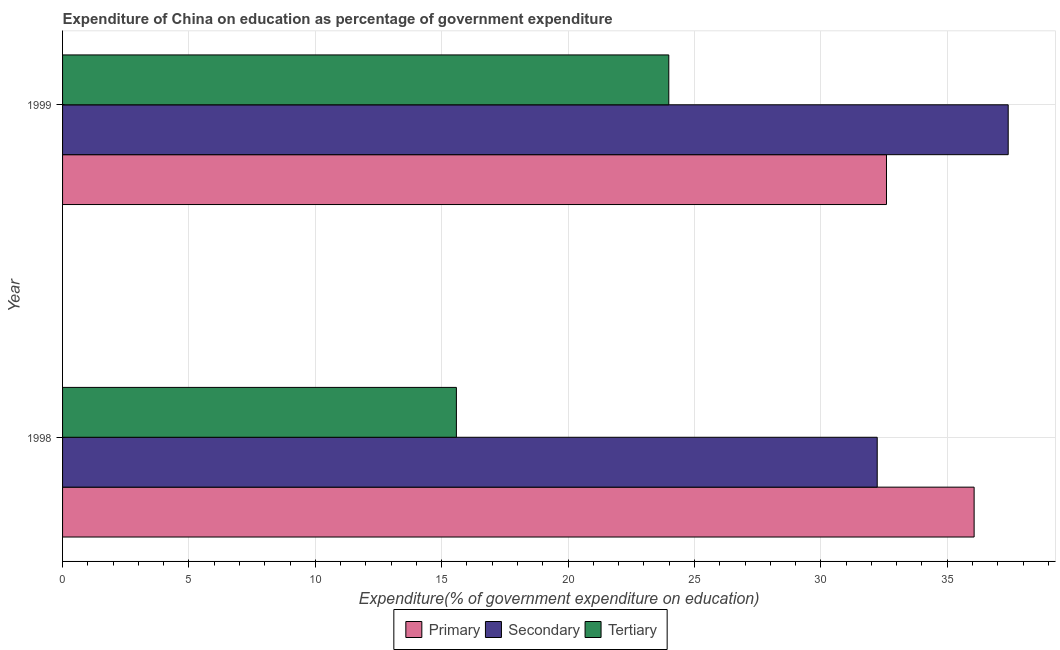How many groups of bars are there?
Provide a succinct answer. 2. How many bars are there on the 1st tick from the bottom?
Give a very brief answer. 3. What is the label of the 1st group of bars from the top?
Offer a terse response. 1999. In how many cases, is the number of bars for a given year not equal to the number of legend labels?
Ensure brevity in your answer.  0. What is the expenditure on secondary education in 1998?
Keep it short and to the point. 32.23. Across all years, what is the maximum expenditure on secondary education?
Make the answer very short. 37.41. Across all years, what is the minimum expenditure on primary education?
Provide a succinct answer. 32.6. In which year was the expenditure on tertiary education maximum?
Keep it short and to the point. 1999. In which year was the expenditure on tertiary education minimum?
Your answer should be compact. 1998. What is the total expenditure on secondary education in the graph?
Provide a succinct answer. 69.64. What is the difference between the expenditure on tertiary education in 1998 and that in 1999?
Your response must be concise. -8.4. What is the difference between the expenditure on secondary education in 1999 and the expenditure on primary education in 1998?
Keep it short and to the point. 1.35. What is the average expenditure on secondary education per year?
Your response must be concise. 34.82. In the year 1999, what is the difference between the expenditure on tertiary education and expenditure on primary education?
Make the answer very short. -8.61. What is the ratio of the expenditure on secondary education in 1998 to that in 1999?
Your answer should be compact. 0.86. Is the expenditure on secondary education in 1998 less than that in 1999?
Give a very brief answer. Yes. In how many years, is the expenditure on secondary education greater than the average expenditure on secondary education taken over all years?
Ensure brevity in your answer.  1. What does the 2nd bar from the top in 1998 represents?
Your answer should be compact. Secondary. What does the 3rd bar from the bottom in 1999 represents?
Ensure brevity in your answer.  Tertiary. Is it the case that in every year, the sum of the expenditure on primary education and expenditure on secondary education is greater than the expenditure on tertiary education?
Provide a succinct answer. Yes. How many bars are there?
Give a very brief answer. 6. How many years are there in the graph?
Provide a succinct answer. 2. What is the difference between two consecutive major ticks on the X-axis?
Make the answer very short. 5. Are the values on the major ticks of X-axis written in scientific E-notation?
Provide a short and direct response. No. Does the graph contain grids?
Keep it short and to the point. Yes. How are the legend labels stacked?
Your response must be concise. Horizontal. What is the title of the graph?
Provide a succinct answer. Expenditure of China on education as percentage of government expenditure. Does "Ages 65 and above" appear as one of the legend labels in the graph?
Make the answer very short. No. What is the label or title of the X-axis?
Provide a succinct answer. Expenditure(% of government expenditure on education). What is the label or title of the Y-axis?
Offer a terse response. Year. What is the Expenditure(% of government expenditure on education) in Primary in 1998?
Offer a very short reply. 36.06. What is the Expenditure(% of government expenditure on education) in Secondary in 1998?
Ensure brevity in your answer.  32.23. What is the Expenditure(% of government expenditure on education) of Tertiary in 1998?
Your response must be concise. 15.58. What is the Expenditure(% of government expenditure on education) of Primary in 1999?
Your response must be concise. 32.6. What is the Expenditure(% of government expenditure on education) in Secondary in 1999?
Make the answer very short. 37.41. What is the Expenditure(% of government expenditure on education) in Tertiary in 1999?
Your answer should be compact. 23.98. Across all years, what is the maximum Expenditure(% of government expenditure on education) in Primary?
Make the answer very short. 36.06. Across all years, what is the maximum Expenditure(% of government expenditure on education) in Secondary?
Give a very brief answer. 37.41. Across all years, what is the maximum Expenditure(% of government expenditure on education) in Tertiary?
Make the answer very short. 23.98. Across all years, what is the minimum Expenditure(% of government expenditure on education) in Primary?
Ensure brevity in your answer.  32.6. Across all years, what is the minimum Expenditure(% of government expenditure on education) of Secondary?
Keep it short and to the point. 32.23. Across all years, what is the minimum Expenditure(% of government expenditure on education) in Tertiary?
Your response must be concise. 15.58. What is the total Expenditure(% of government expenditure on education) in Primary in the graph?
Your response must be concise. 68.66. What is the total Expenditure(% of government expenditure on education) in Secondary in the graph?
Provide a short and direct response. 69.64. What is the total Expenditure(% of government expenditure on education) in Tertiary in the graph?
Keep it short and to the point. 39.56. What is the difference between the Expenditure(% of government expenditure on education) of Primary in 1998 and that in 1999?
Make the answer very short. 3.47. What is the difference between the Expenditure(% of government expenditure on education) in Secondary in 1998 and that in 1999?
Make the answer very short. -5.18. What is the difference between the Expenditure(% of government expenditure on education) of Tertiary in 1998 and that in 1999?
Your answer should be compact. -8.4. What is the difference between the Expenditure(% of government expenditure on education) in Primary in 1998 and the Expenditure(% of government expenditure on education) in Secondary in 1999?
Your response must be concise. -1.35. What is the difference between the Expenditure(% of government expenditure on education) in Primary in 1998 and the Expenditure(% of government expenditure on education) in Tertiary in 1999?
Your answer should be very brief. 12.08. What is the difference between the Expenditure(% of government expenditure on education) in Secondary in 1998 and the Expenditure(% of government expenditure on education) in Tertiary in 1999?
Provide a short and direct response. 8.25. What is the average Expenditure(% of government expenditure on education) in Primary per year?
Offer a terse response. 34.33. What is the average Expenditure(% of government expenditure on education) in Secondary per year?
Your answer should be compact. 34.82. What is the average Expenditure(% of government expenditure on education) in Tertiary per year?
Offer a very short reply. 19.78. In the year 1998, what is the difference between the Expenditure(% of government expenditure on education) in Primary and Expenditure(% of government expenditure on education) in Secondary?
Make the answer very short. 3.83. In the year 1998, what is the difference between the Expenditure(% of government expenditure on education) of Primary and Expenditure(% of government expenditure on education) of Tertiary?
Your answer should be very brief. 20.48. In the year 1998, what is the difference between the Expenditure(% of government expenditure on education) in Secondary and Expenditure(% of government expenditure on education) in Tertiary?
Provide a succinct answer. 16.65. In the year 1999, what is the difference between the Expenditure(% of government expenditure on education) of Primary and Expenditure(% of government expenditure on education) of Secondary?
Keep it short and to the point. -4.82. In the year 1999, what is the difference between the Expenditure(% of government expenditure on education) of Primary and Expenditure(% of government expenditure on education) of Tertiary?
Make the answer very short. 8.61. In the year 1999, what is the difference between the Expenditure(% of government expenditure on education) in Secondary and Expenditure(% of government expenditure on education) in Tertiary?
Give a very brief answer. 13.43. What is the ratio of the Expenditure(% of government expenditure on education) of Primary in 1998 to that in 1999?
Give a very brief answer. 1.11. What is the ratio of the Expenditure(% of government expenditure on education) in Secondary in 1998 to that in 1999?
Your answer should be compact. 0.86. What is the ratio of the Expenditure(% of government expenditure on education) of Tertiary in 1998 to that in 1999?
Make the answer very short. 0.65. What is the difference between the highest and the second highest Expenditure(% of government expenditure on education) of Primary?
Your answer should be very brief. 3.47. What is the difference between the highest and the second highest Expenditure(% of government expenditure on education) of Secondary?
Your answer should be compact. 5.18. What is the difference between the highest and the second highest Expenditure(% of government expenditure on education) of Tertiary?
Give a very brief answer. 8.4. What is the difference between the highest and the lowest Expenditure(% of government expenditure on education) of Primary?
Offer a terse response. 3.47. What is the difference between the highest and the lowest Expenditure(% of government expenditure on education) in Secondary?
Make the answer very short. 5.18. What is the difference between the highest and the lowest Expenditure(% of government expenditure on education) in Tertiary?
Give a very brief answer. 8.4. 